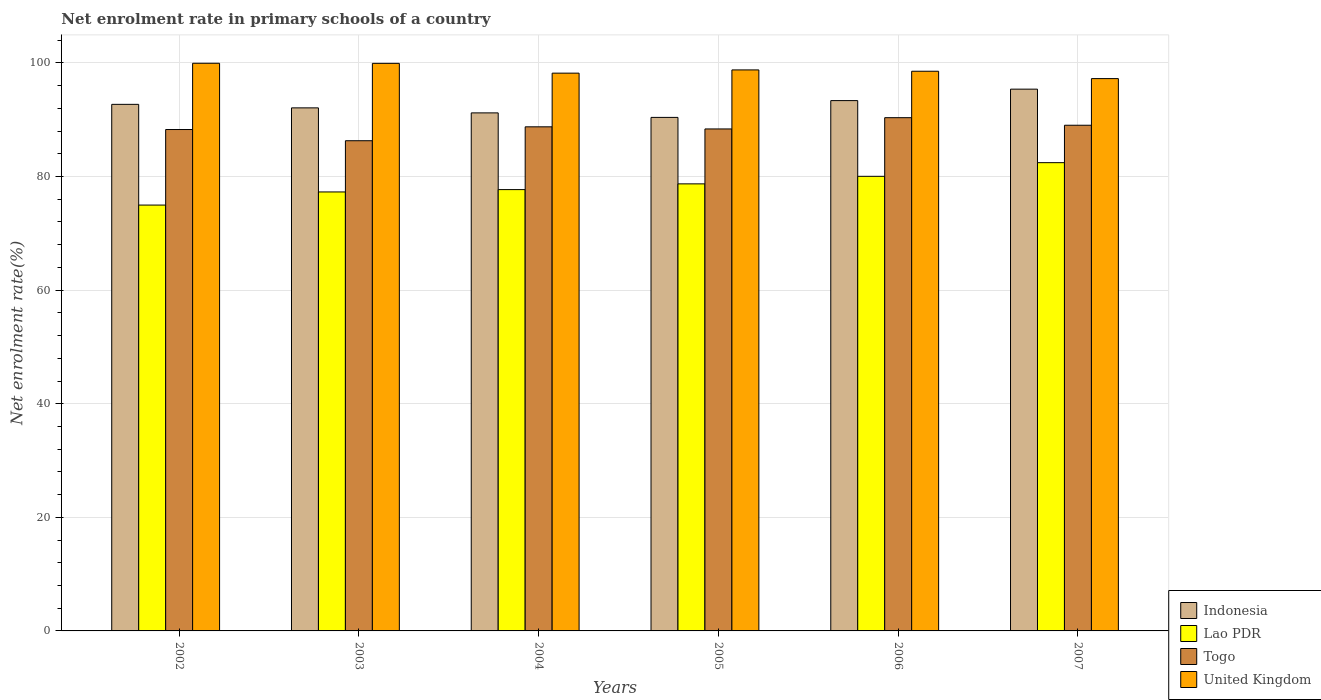Are the number of bars per tick equal to the number of legend labels?
Make the answer very short. Yes. Are the number of bars on each tick of the X-axis equal?
Your answer should be compact. Yes. How many bars are there on the 4th tick from the left?
Offer a terse response. 4. What is the net enrolment rate in primary schools in Lao PDR in 2003?
Make the answer very short. 77.29. Across all years, what is the maximum net enrolment rate in primary schools in Indonesia?
Ensure brevity in your answer.  95.38. Across all years, what is the minimum net enrolment rate in primary schools in Togo?
Your answer should be very brief. 86.3. In which year was the net enrolment rate in primary schools in Togo maximum?
Offer a terse response. 2006. What is the total net enrolment rate in primary schools in Indonesia in the graph?
Provide a short and direct response. 555.16. What is the difference between the net enrolment rate in primary schools in Lao PDR in 2003 and that in 2007?
Give a very brief answer. -5.16. What is the difference between the net enrolment rate in primary schools in Indonesia in 2005 and the net enrolment rate in primary schools in United Kingdom in 2004?
Give a very brief answer. -7.79. What is the average net enrolment rate in primary schools in Togo per year?
Ensure brevity in your answer.  88.52. In the year 2003, what is the difference between the net enrolment rate in primary schools in Togo and net enrolment rate in primary schools in Lao PDR?
Offer a terse response. 9.02. In how many years, is the net enrolment rate in primary schools in Lao PDR greater than 20 %?
Offer a terse response. 6. What is the ratio of the net enrolment rate in primary schools in Lao PDR in 2002 to that in 2005?
Provide a succinct answer. 0.95. Is the net enrolment rate in primary schools in United Kingdom in 2005 less than that in 2007?
Provide a short and direct response. No. What is the difference between the highest and the second highest net enrolment rate in primary schools in Lao PDR?
Make the answer very short. 2.4. What is the difference between the highest and the lowest net enrolment rate in primary schools in Lao PDR?
Offer a terse response. 7.47. What does the 2nd bar from the left in 2005 represents?
Provide a short and direct response. Lao PDR. Are all the bars in the graph horizontal?
Keep it short and to the point. No. How many years are there in the graph?
Make the answer very short. 6. What is the difference between two consecutive major ticks on the Y-axis?
Make the answer very short. 20. Where does the legend appear in the graph?
Your answer should be compact. Bottom right. How are the legend labels stacked?
Keep it short and to the point. Vertical. What is the title of the graph?
Your answer should be very brief. Net enrolment rate in primary schools of a country. What is the label or title of the Y-axis?
Your answer should be compact. Net enrolment rate(%). What is the Net enrolment rate(%) in Indonesia in 2002?
Your answer should be compact. 92.71. What is the Net enrolment rate(%) of Lao PDR in 2002?
Offer a terse response. 74.98. What is the Net enrolment rate(%) of Togo in 2002?
Your response must be concise. 88.28. What is the Net enrolment rate(%) of United Kingdom in 2002?
Provide a short and direct response. 99.94. What is the Net enrolment rate(%) of Indonesia in 2003?
Make the answer very short. 92.09. What is the Net enrolment rate(%) in Lao PDR in 2003?
Offer a very short reply. 77.29. What is the Net enrolment rate(%) of Togo in 2003?
Ensure brevity in your answer.  86.3. What is the Net enrolment rate(%) of United Kingdom in 2003?
Keep it short and to the point. 99.93. What is the Net enrolment rate(%) of Indonesia in 2004?
Offer a very short reply. 91.21. What is the Net enrolment rate(%) of Lao PDR in 2004?
Provide a short and direct response. 77.7. What is the Net enrolment rate(%) in Togo in 2004?
Offer a terse response. 88.75. What is the Net enrolment rate(%) of United Kingdom in 2004?
Your answer should be very brief. 98.2. What is the Net enrolment rate(%) of Indonesia in 2005?
Give a very brief answer. 90.41. What is the Net enrolment rate(%) in Lao PDR in 2005?
Give a very brief answer. 78.71. What is the Net enrolment rate(%) of Togo in 2005?
Offer a terse response. 88.38. What is the Net enrolment rate(%) in United Kingdom in 2005?
Make the answer very short. 98.77. What is the Net enrolment rate(%) in Indonesia in 2006?
Your answer should be very brief. 93.37. What is the Net enrolment rate(%) in Lao PDR in 2006?
Offer a very short reply. 80.04. What is the Net enrolment rate(%) of Togo in 2006?
Your answer should be compact. 90.36. What is the Net enrolment rate(%) in United Kingdom in 2006?
Your response must be concise. 98.54. What is the Net enrolment rate(%) of Indonesia in 2007?
Your answer should be compact. 95.38. What is the Net enrolment rate(%) in Lao PDR in 2007?
Make the answer very short. 82.44. What is the Net enrolment rate(%) in Togo in 2007?
Provide a succinct answer. 89.03. What is the Net enrolment rate(%) in United Kingdom in 2007?
Offer a terse response. 97.24. Across all years, what is the maximum Net enrolment rate(%) of Indonesia?
Provide a short and direct response. 95.38. Across all years, what is the maximum Net enrolment rate(%) of Lao PDR?
Offer a very short reply. 82.44. Across all years, what is the maximum Net enrolment rate(%) in Togo?
Ensure brevity in your answer.  90.36. Across all years, what is the maximum Net enrolment rate(%) in United Kingdom?
Your response must be concise. 99.94. Across all years, what is the minimum Net enrolment rate(%) of Indonesia?
Offer a very short reply. 90.41. Across all years, what is the minimum Net enrolment rate(%) of Lao PDR?
Keep it short and to the point. 74.98. Across all years, what is the minimum Net enrolment rate(%) of Togo?
Ensure brevity in your answer.  86.3. Across all years, what is the minimum Net enrolment rate(%) in United Kingdom?
Provide a succinct answer. 97.24. What is the total Net enrolment rate(%) of Indonesia in the graph?
Offer a very short reply. 555.16. What is the total Net enrolment rate(%) in Lao PDR in the graph?
Provide a short and direct response. 471.15. What is the total Net enrolment rate(%) of Togo in the graph?
Give a very brief answer. 531.1. What is the total Net enrolment rate(%) of United Kingdom in the graph?
Make the answer very short. 592.62. What is the difference between the Net enrolment rate(%) in Indonesia in 2002 and that in 2003?
Your response must be concise. 0.62. What is the difference between the Net enrolment rate(%) in Lao PDR in 2002 and that in 2003?
Keep it short and to the point. -2.31. What is the difference between the Net enrolment rate(%) of Togo in 2002 and that in 2003?
Keep it short and to the point. 1.97. What is the difference between the Net enrolment rate(%) of United Kingdom in 2002 and that in 2003?
Ensure brevity in your answer.  0.02. What is the difference between the Net enrolment rate(%) in Indonesia in 2002 and that in 2004?
Your answer should be compact. 1.5. What is the difference between the Net enrolment rate(%) of Lao PDR in 2002 and that in 2004?
Your response must be concise. -2.72. What is the difference between the Net enrolment rate(%) of Togo in 2002 and that in 2004?
Your answer should be compact. -0.48. What is the difference between the Net enrolment rate(%) of United Kingdom in 2002 and that in 2004?
Ensure brevity in your answer.  1.74. What is the difference between the Net enrolment rate(%) of Indonesia in 2002 and that in 2005?
Provide a short and direct response. 2.3. What is the difference between the Net enrolment rate(%) in Lao PDR in 2002 and that in 2005?
Ensure brevity in your answer.  -3.73. What is the difference between the Net enrolment rate(%) of Togo in 2002 and that in 2005?
Keep it short and to the point. -0.1. What is the difference between the Net enrolment rate(%) in United Kingdom in 2002 and that in 2005?
Ensure brevity in your answer.  1.17. What is the difference between the Net enrolment rate(%) of Indonesia in 2002 and that in 2006?
Give a very brief answer. -0.66. What is the difference between the Net enrolment rate(%) of Lao PDR in 2002 and that in 2006?
Keep it short and to the point. -5.06. What is the difference between the Net enrolment rate(%) of Togo in 2002 and that in 2006?
Offer a very short reply. -2.08. What is the difference between the Net enrolment rate(%) of United Kingdom in 2002 and that in 2006?
Your answer should be compact. 1.41. What is the difference between the Net enrolment rate(%) in Indonesia in 2002 and that in 2007?
Offer a very short reply. -2.68. What is the difference between the Net enrolment rate(%) of Lao PDR in 2002 and that in 2007?
Provide a succinct answer. -7.47. What is the difference between the Net enrolment rate(%) in Togo in 2002 and that in 2007?
Keep it short and to the point. -0.76. What is the difference between the Net enrolment rate(%) in United Kingdom in 2002 and that in 2007?
Offer a very short reply. 2.7. What is the difference between the Net enrolment rate(%) of Indonesia in 2003 and that in 2004?
Your response must be concise. 0.88. What is the difference between the Net enrolment rate(%) in Lao PDR in 2003 and that in 2004?
Your response must be concise. -0.41. What is the difference between the Net enrolment rate(%) in Togo in 2003 and that in 2004?
Provide a succinct answer. -2.45. What is the difference between the Net enrolment rate(%) of United Kingdom in 2003 and that in 2004?
Offer a very short reply. 1.73. What is the difference between the Net enrolment rate(%) of Indonesia in 2003 and that in 2005?
Make the answer very short. 1.68. What is the difference between the Net enrolment rate(%) in Lao PDR in 2003 and that in 2005?
Ensure brevity in your answer.  -1.42. What is the difference between the Net enrolment rate(%) in Togo in 2003 and that in 2005?
Give a very brief answer. -2.08. What is the difference between the Net enrolment rate(%) in United Kingdom in 2003 and that in 2005?
Make the answer very short. 1.16. What is the difference between the Net enrolment rate(%) of Indonesia in 2003 and that in 2006?
Ensure brevity in your answer.  -1.28. What is the difference between the Net enrolment rate(%) in Lao PDR in 2003 and that in 2006?
Provide a short and direct response. -2.75. What is the difference between the Net enrolment rate(%) of Togo in 2003 and that in 2006?
Make the answer very short. -4.06. What is the difference between the Net enrolment rate(%) of United Kingdom in 2003 and that in 2006?
Your response must be concise. 1.39. What is the difference between the Net enrolment rate(%) of Indonesia in 2003 and that in 2007?
Keep it short and to the point. -3.3. What is the difference between the Net enrolment rate(%) in Lao PDR in 2003 and that in 2007?
Give a very brief answer. -5.16. What is the difference between the Net enrolment rate(%) of Togo in 2003 and that in 2007?
Your answer should be compact. -2.73. What is the difference between the Net enrolment rate(%) of United Kingdom in 2003 and that in 2007?
Make the answer very short. 2.69. What is the difference between the Net enrolment rate(%) in Indonesia in 2004 and that in 2005?
Make the answer very short. 0.8. What is the difference between the Net enrolment rate(%) in Lao PDR in 2004 and that in 2005?
Your answer should be compact. -1.01. What is the difference between the Net enrolment rate(%) in Togo in 2004 and that in 2005?
Your response must be concise. 0.37. What is the difference between the Net enrolment rate(%) of United Kingdom in 2004 and that in 2005?
Give a very brief answer. -0.57. What is the difference between the Net enrolment rate(%) in Indonesia in 2004 and that in 2006?
Offer a very short reply. -2.16. What is the difference between the Net enrolment rate(%) of Lao PDR in 2004 and that in 2006?
Ensure brevity in your answer.  -2.34. What is the difference between the Net enrolment rate(%) in Togo in 2004 and that in 2006?
Offer a very short reply. -1.61. What is the difference between the Net enrolment rate(%) of United Kingdom in 2004 and that in 2006?
Keep it short and to the point. -0.34. What is the difference between the Net enrolment rate(%) in Indonesia in 2004 and that in 2007?
Offer a terse response. -4.18. What is the difference between the Net enrolment rate(%) in Lao PDR in 2004 and that in 2007?
Provide a succinct answer. -4.74. What is the difference between the Net enrolment rate(%) of Togo in 2004 and that in 2007?
Your answer should be compact. -0.28. What is the difference between the Net enrolment rate(%) in United Kingdom in 2004 and that in 2007?
Give a very brief answer. 0.96. What is the difference between the Net enrolment rate(%) of Indonesia in 2005 and that in 2006?
Provide a succinct answer. -2.96. What is the difference between the Net enrolment rate(%) of Lao PDR in 2005 and that in 2006?
Your answer should be very brief. -1.33. What is the difference between the Net enrolment rate(%) in Togo in 2005 and that in 2006?
Your answer should be very brief. -1.98. What is the difference between the Net enrolment rate(%) in United Kingdom in 2005 and that in 2006?
Offer a very short reply. 0.24. What is the difference between the Net enrolment rate(%) of Indonesia in 2005 and that in 2007?
Offer a terse response. -4.97. What is the difference between the Net enrolment rate(%) in Lao PDR in 2005 and that in 2007?
Your answer should be compact. -3.73. What is the difference between the Net enrolment rate(%) of Togo in 2005 and that in 2007?
Offer a terse response. -0.65. What is the difference between the Net enrolment rate(%) in United Kingdom in 2005 and that in 2007?
Your answer should be compact. 1.53. What is the difference between the Net enrolment rate(%) in Indonesia in 2006 and that in 2007?
Make the answer very short. -2.02. What is the difference between the Net enrolment rate(%) of Lao PDR in 2006 and that in 2007?
Keep it short and to the point. -2.4. What is the difference between the Net enrolment rate(%) in Togo in 2006 and that in 2007?
Give a very brief answer. 1.33. What is the difference between the Net enrolment rate(%) in United Kingdom in 2006 and that in 2007?
Ensure brevity in your answer.  1.3. What is the difference between the Net enrolment rate(%) in Indonesia in 2002 and the Net enrolment rate(%) in Lao PDR in 2003?
Offer a very short reply. 15.42. What is the difference between the Net enrolment rate(%) of Indonesia in 2002 and the Net enrolment rate(%) of Togo in 2003?
Provide a succinct answer. 6.4. What is the difference between the Net enrolment rate(%) in Indonesia in 2002 and the Net enrolment rate(%) in United Kingdom in 2003?
Make the answer very short. -7.22. What is the difference between the Net enrolment rate(%) of Lao PDR in 2002 and the Net enrolment rate(%) of Togo in 2003?
Offer a very short reply. -11.33. What is the difference between the Net enrolment rate(%) of Lao PDR in 2002 and the Net enrolment rate(%) of United Kingdom in 2003?
Ensure brevity in your answer.  -24.95. What is the difference between the Net enrolment rate(%) of Togo in 2002 and the Net enrolment rate(%) of United Kingdom in 2003?
Provide a succinct answer. -11.65. What is the difference between the Net enrolment rate(%) of Indonesia in 2002 and the Net enrolment rate(%) of Lao PDR in 2004?
Your answer should be very brief. 15.01. What is the difference between the Net enrolment rate(%) in Indonesia in 2002 and the Net enrolment rate(%) in Togo in 2004?
Your response must be concise. 3.96. What is the difference between the Net enrolment rate(%) of Indonesia in 2002 and the Net enrolment rate(%) of United Kingdom in 2004?
Provide a succinct answer. -5.49. What is the difference between the Net enrolment rate(%) of Lao PDR in 2002 and the Net enrolment rate(%) of Togo in 2004?
Offer a very short reply. -13.77. What is the difference between the Net enrolment rate(%) of Lao PDR in 2002 and the Net enrolment rate(%) of United Kingdom in 2004?
Make the answer very short. -23.22. What is the difference between the Net enrolment rate(%) of Togo in 2002 and the Net enrolment rate(%) of United Kingdom in 2004?
Offer a very short reply. -9.92. What is the difference between the Net enrolment rate(%) in Indonesia in 2002 and the Net enrolment rate(%) in Lao PDR in 2005?
Ensure brevity in your answer.  14. What is the difference between the Net enrolment rate(%) of Indonesia in 2002 and the Net enrolment rate(%) of Togo in 2005?
Give a very brief answer. 4.33. What is the difference between the Net enrolment rate(%) in Indonesia in 2002 and the Net enrolment rate(%) in United Kingdom in 2005?
Provide a short and direct response. -6.06. What is the difference between the Net enrolment rate(%) of Lao PDR in 2002 and the Net enrolment rate(%) of Togo in 2005?
Your answer should be very brief. -13.4. What is the difference between the Net enrolment rate(%) of Lao PDR in 2002 and the Net enrolment rate(%) of United Kingdom in 2005?
Ensure brevity in your answer.  -23.8. What is the difference between the Net enrolment rate(%) of Togo in 2002 and the Net enrolment rate(%) of United Kingdom in 2005?
Your answer should be very brief. -10.5. What is the difference between the Net enrolment rate(%) of Indonesia in 2002 and the Net enrolment rate(%) of Lao PDR in 2006?
Offer a very short reply. 12.67. What is the difference between the Net enrolment rate(%) in Indonesia in 2002 and the Net enrolment rate(%) in Togo in 2006?
Offer a very short reply. 2.35. What is the difference between the Net enrolment rate(%) of Indonesia in 2002 and the Net enrolment rate(%) of United Kingdom in 2006?
Keep it short and to the point. -5.83. What is the difference between the Net enrolment rate(%) in Lao PDR in 2002 and the Net enrolment rate(%) in Togo in 2006?
Your response must be concise. -15.38. What is the difference between the Net enrolment rate(%) of Lao PDR in 2002 and the Net enrolment rate(%) of United Kingdom in 2006?
Offer a terse response. -23.56. What is the difference between the Net enrolment rate(%) of Togo in 2002 and the Net enrolment rate(%) of United Kingdom in 2006?
Your response must be concise. -10.26. What is the difference between the Net enrolment rate(%) of Indonesia in 2002 and the Net enrolment rate(%) of Lao PDR in 2007?
Your answer should be compact. 10.26. What is the difference between the Net enrolment rate(%) in Indonesia in 2002 and the Net enrolment rate(%) in Togo in 2007?
Offer a very short reply. 3.68. What is the difference between the Net enrolment rate(%) of Indonesia in 2002 and the Net enrolment rate(%) of United Kingdom in 2007?
Make the answer very short. -4.53. What is the difference between the Net enrolment rate(%) of Lao PDR in 2002 and the Net enrolment rate(%) of Togo in 2007?
Provide a short and direct response. -14.05. What is the difference between the Net enrolment rate(%) in Lao PDR in 2002 and the Net enrolment rate(%) in United Kingdom in 2007?
Your answer should be very brief. -22.26. What is the difference between the Net enrolment rate(%) of Togo in 2002 and the Net enrolment rate(%) of United Kingdom in 2007?
Your answer should be very brief. -8.97. What is the difference between the Net enrolment rate(%) of Indonesia in 2003 and the Net enrolment rate(%) of Lao PDR in 2004?
Give a very brief answer. 14.39. What is the difference between the Net enrolment rate(%) of Indonesia in 2003 and the Net enrolment rate(%) of Togo in 2004?
Ensure brevity in your answer.  3.34. What is the difference between the Net enrolment rate(%) in Indonesia in 2003 and the Net enrolment rate(%) in United Kingdom in 2004?
Offer a very short reply. -6.11. What is the difference between the Net enrolment rate(%) in Lao PDR in 2003 and the Net enrolment rate(%) in Togo in 2004?
Provide a short and direct response. -11.47. What is the difference between the Net enrolment rate(%) in Lao PDR in 2003 and the Net enrolment rate(%) in United Kingdom in 2004?
Make the answer very short. -20.91. What is the difference between the Net enrolment rate(%) in Togo in 2003 and the Net enrolment rate(%) in United Kingdom in 2004?
Ensure brevity in your answer.  -11.9. What is the difference between the Net enrolment rate(%) of Indonesia in 2003 and the Net enrolment rate(%) of Lao PDR in 2005?
Keep it short and to the point. 13.38. What is the difference between the Net enrolment rate(%) in Indonesia in 2003 and the Net enrolment rate(%) in Togo in 2005?
Ensure brevity in your answer.  3.71. What is the difference between the Net enrolment rate(%) of Indonesia in 2003 and the Net enrolment rate(%) of United Kingdom in 2005?
Make the answer very short. -6.68. What is the difference between the Net enrolment rate(%) of Lao PDR in 2003 and the Net enrolment rate(%) of Togo in 2005?
Keep it short and to the point. -11.09. What is the difference between the Net enrolment rate(%) in Lao PDR in 2003 and the Net enrolment rate(%) in United Kingdom in 2005?
Provide a short and direct response. -21.49. What is the difference between the Net enrolment rate(%) in Togo in 2003 and the Net enrolment rate(%) in United Kingdom in 2005?
Provide a short and direct response. -12.47. What is the difference between the Net enrolment rate(%) in Indonesia in 2003 and the Net enrolment rate(%) in Lao PDR in 2006?
Offer a very short reply. 12.05. What is the difference between the Net enrolment rate(%) of Indonesia in 2003 and the Net enrolment rate(%) of Togo in 2006?
Give a very brief answer. 1.73. What is the difference between the Net enrolment rate(%) in Indonesia in 2003 and the Net enrolment rate(%) in United Kingdom in 2006?
Your answer should be very brief. -6.45. What is the difference between the Net enrolment rate(%) in Lao PDR in 2003 and the Net enrolment rate(%) in Togo in 2006?
Provide a short and direct response. -13.07. What is the difference between the Net enrolment rate(%) of Lao PDR in 2003 and the Net enrolment rate(%) of United Kingdom in 2006?
Keep it short and to the point. -21.25. What is the difference between the Net enrolment rate(%) in Togo in 2003 and the Net enrolment rate(%) in United Kingdom in 2006?
Make the answer very short. -12.23. What is the difference between the Net enrolment rate(%) in Indonesia in 2003 and the Net enrolment rate(%) in Lao PDR in 2007?
Your answer should be compact. 9.65. What is the difference between the Net enrolment rate(%) in Indonesia in 2003 and the Net enrolment rate(%) in Togo in 2007?
Offer a terse response. 3.06. What is the difference between the Net enrolment rate(%) in Indonesia in 2003 and the Net enrolment rate(%) in United Kingdom in 2007?
Your answer should be compact. -5.15. What is the difference between the Net enrolment rate(%) in Lao PDR in 2003 and the Net enrolment rate(%) in Togo in 2007?
Give a very brief answer. -11.74. What is the difference between the Net enrolment rate(%) of Lao PDR in 2003 and the Net enrolment rate(%) of United Kingdom in 2007?
Provide a succinct answer. -19.95. What is the difference between the Net enrolment rate(%) of Togo in 2003 and the Net enrolment rate(%) of United Kingdom in 2007?
Make the answer very short. -10.94. What is the difference between the Net enrolment rate(%) of Indonesia in 2004 and the Net enrolment rate(%) of Lao PDR in 2005?
Provide a short and direct response. 12.5. What is the difference between the Net enrolment rate(%) of Indonesia in 2004 and the Net enrolment rate(%) of Togo in 2005?
Offer a terse response. 2.83. What is the difference between the Net enrolment rate(%) of Indonesia in 2004 and the Net enrolment rate(%) of United Kingdom in 2005?
Give a very brief answer. -7.57. What is the difference between the Net enrolment rate(%) in Lao PDR in 2004 and the Net enrolment rate(%) in Togo in 2005?
Your answer should be very brief. -10.68. What is the difference between the Net enrolment rate(%) in Lao PDR in 2004 and the Net enrolment rate(%) in United Kingdom in 2005?
Your answer should be very brief. -21.07. What is the difference between the Net enrolment rate(%) of Togo in 2004 and the Net enrolment rate(%) of United Kingdom in 2005?
Your answer should be very brief. -10.02. What is the difference between the Net enrolment rate(%) in Indonesia in 2004 and the Net enrolment rate(%) in Lao PDR in 2006?
Offer a very short reply. 11.17. What is the difference between the Net enrolment rate(%) in Indonesia in 2004 and the Net enrolment rate(%) in Togo in 2006?
Provide a succinct answer. 0.85. What is the difference between the Net enrolment rate(%) in Indonesia in 2004 and the Net enrolment rate(%) in United Kingdom in 2006?
Keep it short and to the point. -7.33. What is the difference between the Net enrolment rate(%) in Lao PDR in 2004 and the Net enrolment rate(%) in Togo in 2006?
Keep it short and to the point. -12.66. What is the difference between the Net enrolment rate(%) in Lao PDR in 2004 and the Net enrolment rate(%) in United Kingdom in 2006?
Keep it short and to the point. -20.84. What is the difference between the Net enrolment rate(%) of Togo in 2004 and the Net enrolment rate(%) of United Kingdom in 2006?
Your answer should be compact. -9.79. What is the difference between the Net enrolment rate(%) of Indonesia in 2004 and the Net enrolment rate(%) of Lao PDR in 2007?
Offer a very short reply. 8.76. What is the difference between the Net enrolment rate(%) of Indonesia in 2004 and the Net enrolment rate(%) of Togo in 2007?
Make the answer very short. 2.18. What is the difference between the Net enrolment rate(%) of Indonesia in 2004 and the Net enrolment rate(%) of United Kingdom in 2007?
Offer a very short reply. -6.03. What is the difference between the Net enrolment rate(%) in Lao PDR in 2004 and the Net enrolment rate(%) in Togo in 2007?
Ensure brevity in your answer.  -11.33. What is the difference between the Net enrolment rate(%) in Lao PDR in 2004 and the Net enrolment rate(%) in United Kingdom in 2007?
Keep it short and to the point. -19.54. What is the difference between the Net enrolment rate(%) in Togo in 2004 and the Net enrolment rate(%) in United Kingdom in 2007?
Offer a terse response. -8.49. What is the difference between the Net enrolment rate(%) of Indonesia in 2005 and the Net enrolment rate(%) of Lao PDR in 2006?
Ensure brevity in your answer.  10.37. What is the difference between the Net enrolment rate(%) in Indonesia in 2005 and the Net enrolment rate(%) in Togo in 2006?
Your answer should be compact. 0.05. What is the difference between the Net enrolment rate(%) of Indonesia in 2005 and the Net enrolment rate(%) of United Kingdom in 2006?
Your answer should be compact. -8.13. What is the difference between the Net enrolment rate(%) of Lao PDR in 2005 and the Net enrolment rate(%) of Togo in 2006?
Ensure brevity in your answer.  -11.65. What is the difference between the Net enrolment rate(%) in Lao PDR in 2005 and the Net enrolment rate(%) in United Kingdom in 2006?
Your response must be concise. -19.83. What is the difference between the Net enrolment rate(%) of Togo in 2005 and the Net enrolment rate(%) of United Kingdom in 2006?
Offer a terse response. -10.16. What is the difference between the Net enrolment rate(%) in Indonesia in 2005 and the Net enrolment rate(%) in Lao PDR in 2007?
Your answer should be compact. 7.97. What is the difference between the Net enrolment rate(%) in Indonesia in 2005 and the Net enrolment rate(%) in Togo in 2007?
Make the answer very short. 1.38. What is the difference between the Net enrolment rate(%) in Indonesia in 2005 and the Net enrolment rate(%) in United Kingdom in 2007?
Offer a terse response. -6.83. What is the difference between the Net enrolment rate(%) of Lao PDR in 2005 and the Net enrolment rate(%) of Togo in 2007?
Offer a very short reply. -10.32. What is the difference between the Net enrolment rate(%) in Lao PDR in 2005 and the Net enrolment rate(%) in United Kingdom in 2007?
Your answer should be very brief. -18.53. What is the difference between the Net enrolment rate(%) of Togo in 2005 and the Net enrolment rate(%) of United Kingdom in 2007?
Your answer should be compact. -8.86. What is the difference between the Net enrolment rate(%) in Indonesia in 2006 and the Net enrolment rate(%) in Lao PDR in 2007?
Offer a very short reply. 10.92. What is the difference between the Net enrolment rate(%) of Indonesia in 2006 and the Net enrolment rate(%) of Togo in 2007?
Your answer should be compact. 4.34. What is the difference between the Net enrolment rate(%) of Indonesia in 2006 and the Net enrolment rate(%) of United Kingdom in 2007?
Offer a terse response. -3.87. What is the difference between the Net enrolment rate(%) in Lao PDR in 2006 and the Net enrolment rate(%) in Togo in 2007?
Provide a succinct answer. -8.99. What is the difference between the Net enrolment rate(%) of Lao PDR in 2006 and the Net enrolment rate(%) of United Kingdom in 2007?
Offer a very short reply. -17.2. What is the difference between the Net enrolment rate(%) of Togo in 2006 and the Net enrolment rate(%) of United Kingdom in 2007?
Provide a succinct answer. -6.88. What is the average Net enrolment rate(%) in Indonesia per year?
Your answer should be compact. 92.53. What is the average Net enrolment rate(%) of Lao PDR per year?
Make the answer very short. 78.52. What is the average Net enrolment rate(%) in Togo per year?
Provide a succinct answer. 88.52. What is the average Net enrolment rate(%) in United Kingdom per year?
Your answer should be compact. 98.77. In the year 2002, what is the difference between the Net enrolment rate(%) of Indonesia and Net enrolment rate(%) of Lao PDR?
Provide a succinct answer. 17.73. In the year 2002, what is the difference between the Net enrolment rate(%) of Indonesia and Net enrolment rate(%) of Togo?
Offer a terse response. 4.43. In the year 2002, what is the difference between the Net enrolment rate(%) in Indonesia and Net enrolment rate(%) in United Kingdom?
Give a very brief answer. -7.24. In the year 2002, what is the difference between the Net enrolment rate(%) in Lao PDR and Net enrolment rate(%) in Togo?
Give a very brief answer. -13.3. In the year 2002, what is the difference between the Net enrolment rate(%) in Lao PDR and Net enrolment rate(%) in United Kingdom?
Provide a succinct answer. -24.97. In the year 2002, what is the difference between the Net enrolment rate(%) in Togo and Net enrolment rate(%) in United Kingdom?
Ensure brevity in your answer.  -11.67. In the year 2003, what is the difference between the Net enrolment rate(%) in Indonesia and Net enrolment rate(%) in Lao PDR?
Your answer should be very brief. 14.8. In the year 2003, what is the difference between the Net enrolment rate(%) of Indonesia and Net enrolment rate(%) of Togo?
Make the answer very short. 5.79. In the year 2003, what is the difference between the Net enrolment rate(%) of Indonesia and Net enrolment rate(%) of United Kingdom?
Your answer should be very brief. -7.84. In the year 2003, what is the difference between the Net enrolment rate(%) of Lao PDR and Net enrolment rate(%) of Togo?
Keep it short and to the point. -9.02. In the year 2003, what is the difference between the Net enrolment rate(%) of Lao PDR and Net enrolment rate(%) of United Kingdom?
Your answer should be compact. -22.64. In the year 2003, what is the difference between the Net enrolment rate(%) in Togo and Net enrolment rate(%) in United Kingdom?
Make the answer very short. -13.62. In the year 2004, what is the difference between the Net enrolment rate(%) in Indonesia and Net enrolment rate(%) in Lao PDR?
Your answer should be very brief. 13.51. In the year 2004, what is the difference between the Net enrolment rate(%) of Indonesia and Net enrolment rate(%) of Togo?
Offer a very short reply. 2.46. In the year 2004, what is the difference between the Net enrolment rate(%) of Indonesia and Net enrolment rate(%) of United Kingdom?
Your response must be concise. -6.99. In the year 2004, what is the difference between the Net enrolment rate(%) of Lao PDR and Net enrolment rate(%) of Togo?
Keep it short and to the point. -11.05. In the year 2004, what is the difference between the Net enrolment rate(%) of Lao PDR and Net enrolment rate(%) of United Kingdom?
Give a very brief answer. -20.5. In the year 2004, what is the difference between the Net enrolment rate(%) of Togo and Net enrolment rate(%) of United Kingdom?
Make the answer very short. -9.45. In the year 2005, what is the difference between the Net enrolment rate(%) in Indonesia and Net enrolment rate(%) in Lao PDR?
Keep it short and to the point. 11.7. In the year 2005, what is the difference between the Net enrolment rate(%) of Indonesia and Net enrolment rate(%) of Togo?
Your answer should be compact. 2.03. In the year 2005, what is the difference between the Net enrolment rate(%) in Indonesia and Net enrolment rate(%) in United Kingdom?
Your answer should be very brief. -8.36. In the year 2005, what is the difference between the Net enrolment rate(%) of Lao PDR and Net enrolment rate(%) of Togo?
Make the answer very short. -9.67. In the year 2005, what is the difference between the Net enrolment rate(%) of Lao PDR and Net enrolment rate(%) of United Kingdom?
Your response must be concise. -20.06. In the year 2005, what is the difference between the Net enrolment rate(%) of Togo and Net enrolment rate(%) of United Kingdom?
Make the answer very short. -10.39. In the year 2006, what is the difference between the Net enrolment rate(%) of Indonesia and Net enrolment rate(%) of Lao PDR?
Give a very brief answer. 13.33. In the year 2006, what is the difference between the Net enrolment rate(%) in Indonesia and Net enrolment rate(%) in Togo?
Offer a very short reply. 3.01. In the year 2006, what is the difference between the Net enrolment rate(%) in Indonesia and Net enrolment rate(%) in United Kingdom?
Provide a short and direct response. -5.17. In the year 2006, what is the difference between the Net enrolment rate(%) of Lao PDR and Net enrolment rate(%) of Togo?
Provide a succinct answer. -10.32. In the year 2006, what is the difference between the Net enrolment rate(%) of Lao PDR and Net enrolment rate(%) of United Kingdom?
Provide a short and direct response. -18.5. In the year 2006, what is the difference between the Net enrolment rate(%) of Togo and Net enrolment rate(%) of United Kingdom?
Ensure brevity in your answer.  -8.18. In the year 2007, what is the difference between the Net enrolment rate(%) in Indonesia and Net enrolment rate(%) in Lao PDR?
Make the answer very short. 12.94. In the year 2007, what is the difference between the Net enrolment rate(%) in Indonesia and Net enrolment rate(%) in Togo?
Offer a terse response. 6.35. In the year 2007, what is the difference between the Net enrolment rate(%) of Indonesia and Net enrolment rate(%) of United Kingdom?
Provide a succinct answer. -1.86. In the year 2007, what is the difference between the Net enrolment rate(%) in Lao PDR and Net enrolment rate(%) in Togo?
Your answer should be compact. -6.59. In the year 2007, what is the difference between the Net enrolment rate(%) in Lao PDR and Net enrolment rate(%) in United Kingdom?
Offer a terse response. -14.8. In the year 2007, what is the difference between the Net enrolment rate(%) in Togo and Net enrolment rate(%) in United Kingdom?
Make the answer very short. -8.21. What is the ratio of the Net enrolment rate(%) in Lao PDR in 2002 to that in 2003?
Make the answer very short. 0.97. What is the ratio of the Net enrolment rate(%) in Togo in 2002 to that in 2003?
Offer a very short reply. 1.02. What is the ratio of the Net enrolment rate(%) of Indonesia in 2002 to that in 2004?
Offer a very short reply. 1.02. What is the ratio of the Net enrolment rate(%) in Togo in 2002 to that in 2004?
Your response must be concise. 0.99. What is the ratio of the Net enrolment rate(%) of United Kingdom in 2002 to that in 2004?
Your answer should be compact. 1.02. What is the ratio of the Net enrolment rate(%) in Indonesia in 2002 to that in 2005?
Make the answer very short. 1.03. What is the ratio of the Net enrolment rate(%) in Lao PDR in 2002 to that in 2005?
Offer a very short reply. 0.95. What is the ratio of the Net enrolment rate(%) of United Kingdom in 2002 to that in 2005?
Your answer should be very brief. 1.01. What is the ratio of the Net enrolment rate(%) in Lao PDR in 2002 to that in 2006?
Your answer should be very brief. 0.94. What is the ratio of the Net enrolment rate(%) of Togo in 2002 to that in 2006?
Offer a very short reply. 0.98. What is the ratio of the Net enrolment rate(%) of United Kingdom in 2002 to that in 2006?
Offer a very short reply. 1.01. What is the ratio of the Net enrolment rate(%) in Indonesia in 2002 to that in 2007?
Offer a very short reply. 0.97. What is the ratio of the Net enrolment rate(%) in Lao PDR in 2002 to that in 2007?
Provide a short and direct response. 0.91. What is the ratio of the Net enrolment rate(%) of United Kingdom in 2002 to that in 2007?
Provide a succinct answer. 1.03. What is the ratio of the Net enrolment rate(%) of Indonesia in 2003 to that in 2004?
Offer a very short reply. 1.01. What is the ratio of the Net enrolment rate(%) in Lao PDR in 2003 to that in 2004?
Give a very brief answer. 0.99. What is the ratio of the Net enrolment rate(%) in Togo in 2003 to that in 2004?
Keep it short and to the point. 0.97. What is the ratio of the Net enrolment rate(%) of United Kingdom in 2003 to that in 2004?
Your response must be concise. 1.02. What is the ratio of the Net enrolment rate(%) in Indonesia in 2003 to that in 2005?
Give a very brief answer. 1.02. What is the ratio of the Net enrolment rate(%) in Lao PDR in 2003 to that in 2005?
Make the answer very short. 0.98. What is the ratio of the Net enrolment rate(%) of Togo in 2003 to that in 2005?
Your response must be concise. 0.98. What is the ratio of the Net enrolment rate(%) in United Kingdom in 2003 to that in 2005?
Your answer should be compact. 1.01. What is the ratio of the Net enrolment rate(%) in Indonesia in 2003 to that in 2006?
Your answer should be very brief. 0.99. What is the ratio of the Net enrolment rate(%) in Lao PDR in 2003 to that in 2006?
Your answer should be compact. 0.97. What is the ratio of the Net enrolment rate(%) of Togo in 2003 to that in 2006?
Keep it short and to the point. 0.96. What is the ratio of the Net enrolment rate(%) of United Kingdom in 2003 to that in 2006?
Your answer should be very brief. 1.01. What is the ratio of the Net enrolment rate(%) in Indonesia in 2003 to that in 2007?
Give a very brief answer. 0.97. What is the ratio of the Net enrolment rate(%) of Lao PDR in 2003 to that in 2007?
Offer a terse response. 0.94. What is the ratio of the Net enrolment rate(%) of Togo in 2003 to that in 2007?
Keep it short and to the point. 0.97. What is the ratio of the Net enrolment rate(%) in United Kingdom in 2003 to that in 2007?
Provide a succinct answer. 1.03. What is the ratio of the Net enrolment rate(%) in Indonesia in 2004 to that in 2005?
Ensure brevity in your answer.  1.01. What is the ratio of the Net enrolment rate(%) of Lao PDR in 2004 to that in 2005?
Provide a short and direct response. 0.99. What is the ratio of the Net enrolment rate(%) in Indonesia in 2004 to that in 2006?
Provide a short and direct response. 0.98. What is the ratio of the Net enrolment rate(%) of Lao PDR in 2004 to that in 2006?
Give a very brief answer. 0.97. What is the ratio of the Net enrolment rate(%) of Togo in 2004 to that in 2006?
Ensure brevity in your answer.  0.98. What is the ratio of the Net enrolment rate(%) in United Kingdom in 2004 to that in 2006?
Your answer should be very brief. 1. What is the ratio of the Net enrolment rate(%) in Indonesia in 2004 to that in 2007?
Your answer should be compact. 0.96. What is the ratio of the Net enrolment rate(%) of Lao PDR in 2004 to that in 2007?
Keep it short and to the point. 0.94. What is the ratio of the Net enrolment rate(%) in United Kingdom in 2004 to that in 2007?
Your answer should be very brief. 1.01. What is the ratio of the Net enrolment rate(%) in Indonesia in 2005 to that in 2006?
Your answer should be compact. 0.97. What is the ratio of the Net enrolment rate(%) of Lao PDR in 2005 to that in 2006?
Provide a succinct answer. 0.98. What is the ratio of the Net enrolment rate(%) in Togo in 2005 to that in 2006?
Your answer should be very brief. 0.98. What is the ratio of the Net enrolment rate(%) in United Kingdom in 2005 to that in 2006?
Offer a very short reply. 1. What is the ratio of the Net enrolment rate(%) in Indonesia in 2005 to that in 2007?
Ensure brevity in your answer.  0.95. What is the ratio of the Net enrolment rate(%) in Lao PDR in 2005 to that in 2007?
Offer a very short reply. 0.95. What is the ratio of the Net enrolment rate(%) of United Kingdom in 2005 to that in 2007?
Make the answer very short. 1.02. What is the ratio of the Net enrolment rate(%) in Indonesia in 2006 to that in 2007?
Provide a short and direct response. 0.98. What is the ratio of the Net enrolment rate(%) in Lao PDR in 2006 to that in 2007?
Your answer should be very brief. 0.97. What is the ratio of the Net enrolment rate(%) of Togo in 2006 to that in 2007?
Provide a succinct answer. 1.01. What is the ratio of the Net enrolment rate(%) of United Kingdom in 2006 to that in 2007?
Give a very brief answer. 1.01. What is the difference between the highest and the second highest Net enrolment rate(%) of Indonesia?
Provide a short and direct response. 2.02. What is the difference between the highest and the second highest Net enrolment rate(%) of Lao PDR?
Offer a very short reply. 2.4. What is the difference between the highest and the second highest Net enrolment rate(%) in Togo?
Make the answer very short. 1.33. What is the difference between the highest and the second highest Net enrolment rate(%) of United Kingdom?
Your answer should be compact. 0.02. What is the difference between the highest and the lowest Net enrolment rate(%) in Indonesia?
Provide a short and direct response. 4.97. What is the difference between the highest and the lowest Net enrolment rate(%) in Lao PDR?
Provide a succinct answer. 7.47. What is the difference between the highest and the lowest Net enrolment rate(%) of Togo?
Provide a succinct answer. 4.06. What is the difference between the highest and the lowest Net enrolment rate(%) of United Kingdom?
Your answer should be very brief. 2.7. 